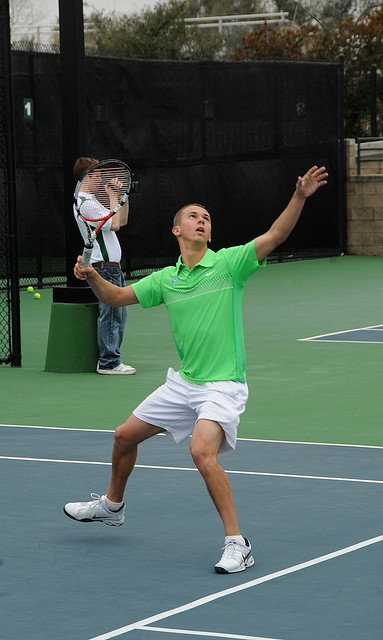Describe the objects in this image and their specific colors. I can see people in black, lightgreen, lightgray, and gray tones, people in black, darkgray, gray, and lavender tones, tennis racket in black, darkgray, gray, and lavender tones, people in black, darkgray, gray, and lightgray tones, and sports ball in black, green, olive, and lightgreen tones in this image. 